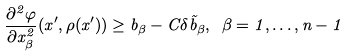Convert formula to latex. <formula><loc_0><loc_0><loc_500><loc_500>\frac { \partial ^ { 2 } \varphi } { \partial x _ { \beta } ^ { 2 } } ( x ^ { \prime } , \rho ( x ^ { \prime } ) ) \geq b _ { \beta } - C \delta \tilde { b } _ { \beta } , \ \beta = 1 , \dots , n - 1</formula> 